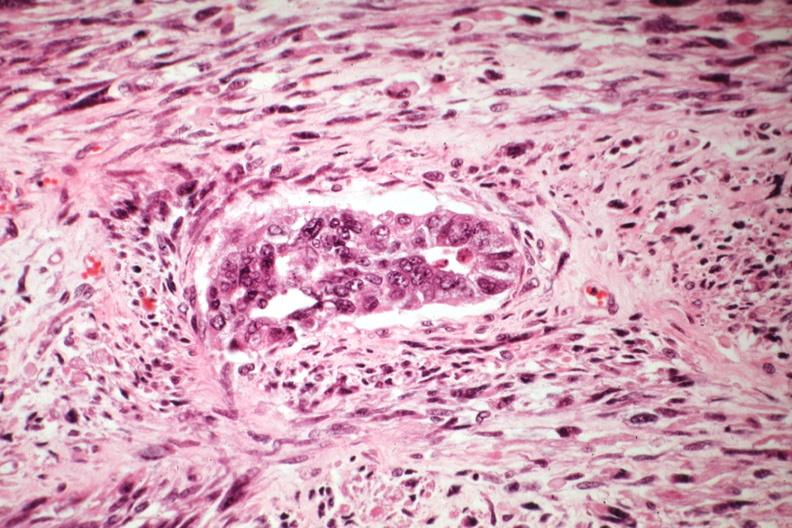s rocky mountain present?
Answer the question using a single word or phrase. No 